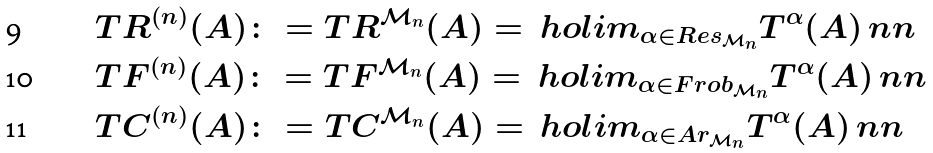Convert formula to latex. <formula><loc_0><loc_0><loc_500><loc_500>& T R ^ { ( n ) } ( A ) \colon = T R ^ { \mathcal { M } _ { n } } ( A ) = \ h o l i m _ { \alpha \in R e s _ { \mathcal { M } _ { n } } } T ^ { \alpha } ( A ) \ n n \\ & T F ^ { ( n ) } ( A ) \colon = T F ^ { \mathcal { M } _ { n } } ( A ) = \ h o l i m _ { \alpha \in F r o b _ { \mathcal { M } _ { n } } } T ^ { \alpha } ( A ) \ n n \\ & T C ^ { ( n ) } ( A ) \colon = T C ^ { \mathcal { M } _ { n } } ( A ) = \ h o l i m _ { \alpha \in A r _ { \mathcal { M } _ { n } } } T ^ { \alpha } ( A ) \ n n</formula> 